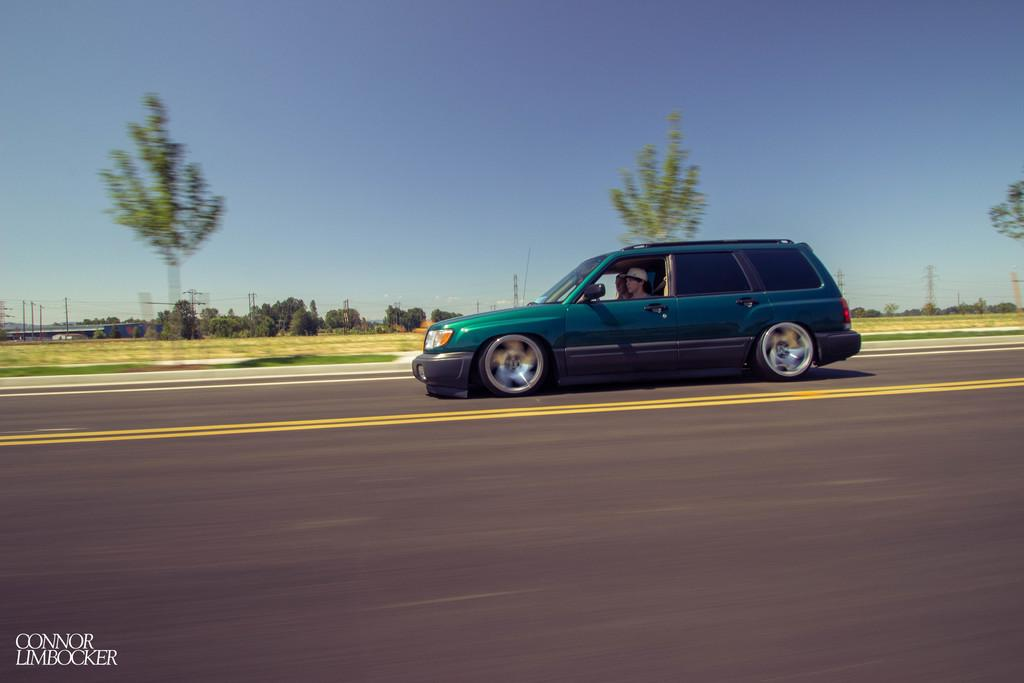What is the main subject of the image? There is a vehicle in the image. Who is inside the vehicle? There are two persons sitting in the vehicle. What can be seen in the background of the image? There are trees and electric poles in the background of the image. What is the color of the sky in the image? The sky is blue and white in color. What religious symbol can be seen on the vehicle in the image? There is no religious symbol visible on the vehicle in the image. What is the cause of the vehicle moving in the image? The image is a still photograph, so the vehicle is not moving, and therefore there is no cause for movement. 